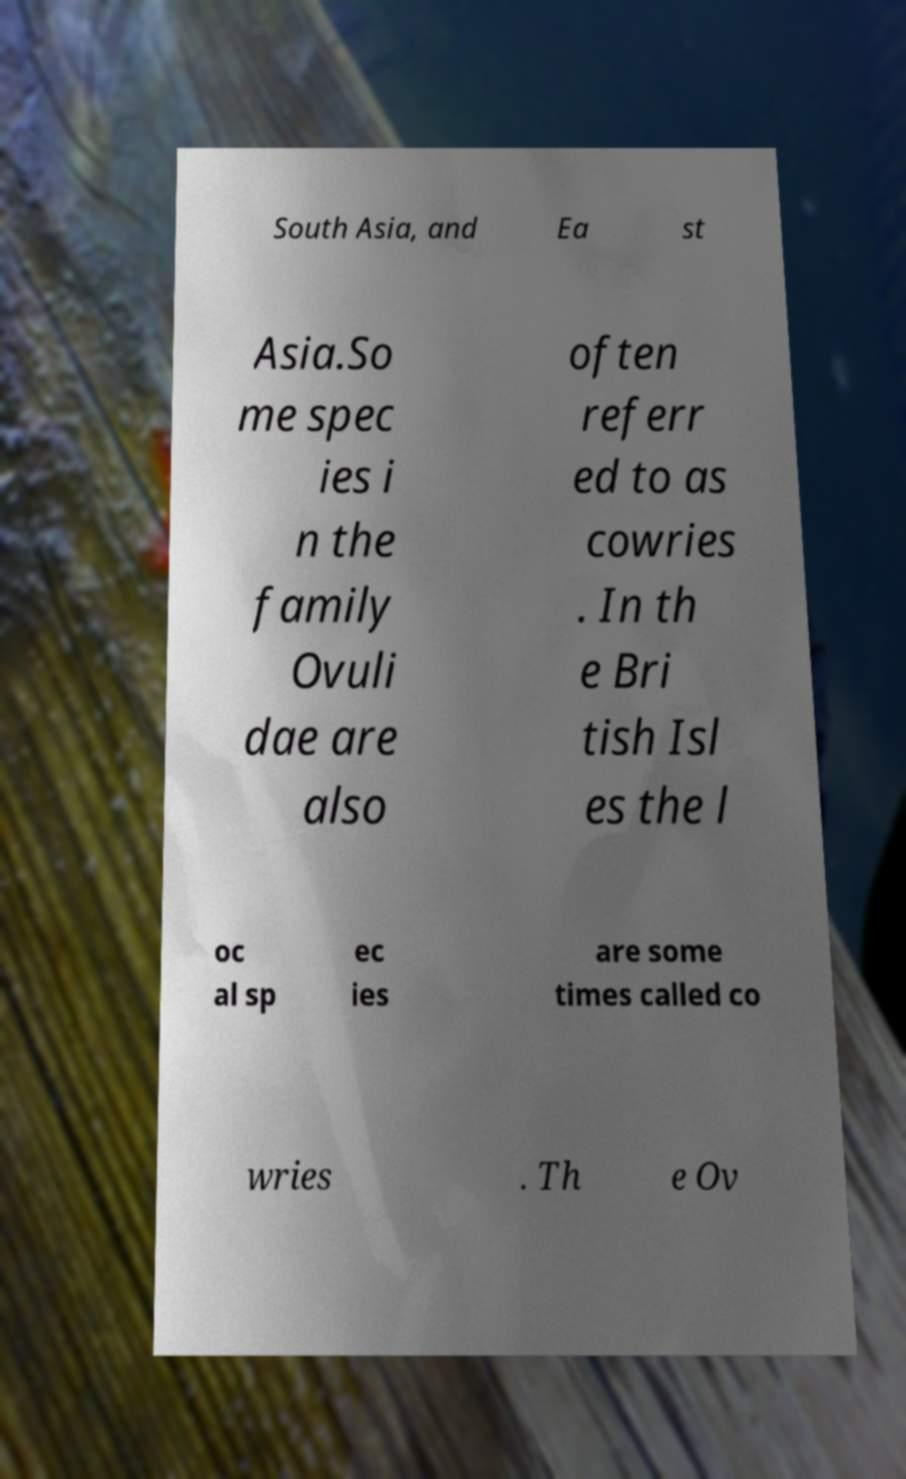Can you accurately transcribe the text from the provided image for me? South Asia, and Ea st Asia.So me spec ies i n the family Ovuli dae are also often referr ed to as cowries . In th e Bri tish Isl es the l oc al sp ec ies are some times called co wries . Th e Ov 